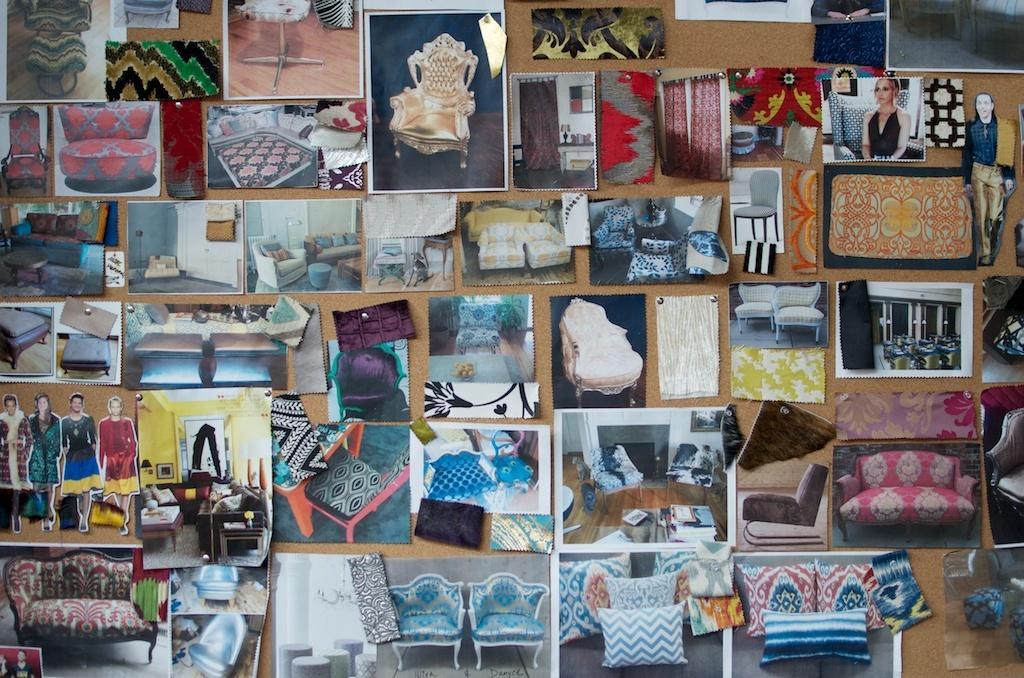Please provide a concise description of this image. This picture shows a notice board where all the photographs pinned to it 